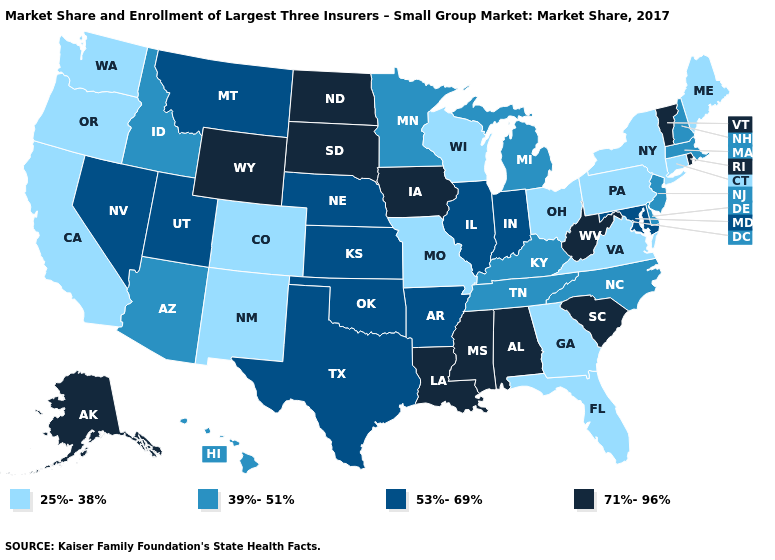What is the value of Wyoming?
Give a very brief answer. 71%-96%. Does Massachusetts have a higher value than Wisconsin?
Concise answer only. Yes. Does California have the same value as New Mexico?
Answer briefly. Yes. What is the highest value in the MidWest ?
Keep it brief. 71%-96%. Name the states that have a value in the range 71%-96%?
Write a very short answer. Alabama, Alaska, Iowa, Louisiana, Mississippi, North Dakota, Rhode Island, South Carolina, South Dakota, Vermont, West Virginia, Wyoming. What is the value of Indiana?
Short answer required. 53%-69%. What is the highest value in states that border Florida?
Answer briefly. 71%-96%. Does Arizona have the lowest value in the USA?
Quick response, please. No. What is the value of Delaware?
Write a very short answer. 39%-51%. Among the states that border Connecticut , does Rhode Island have the highest value?
Concise answer only. Yes. What is the value of Missouri?
Concise answer only. 25%-38%. Name the states that have a value in the range 39%-51%?
Answer briefly. Arizona, Delaware, Hawaii, Idaho, Kentucky, Massachusetts, Michigan, Minnesota, New Hampshire, New Jersey, North Carolina, Tennessee. What is the value of Washington?
Write a very short answer. 25%-38%. Is the legend a continuous bar?
Give a very brief answer. No. What is the value of New York?
Keep it brief. 25%-38%. 